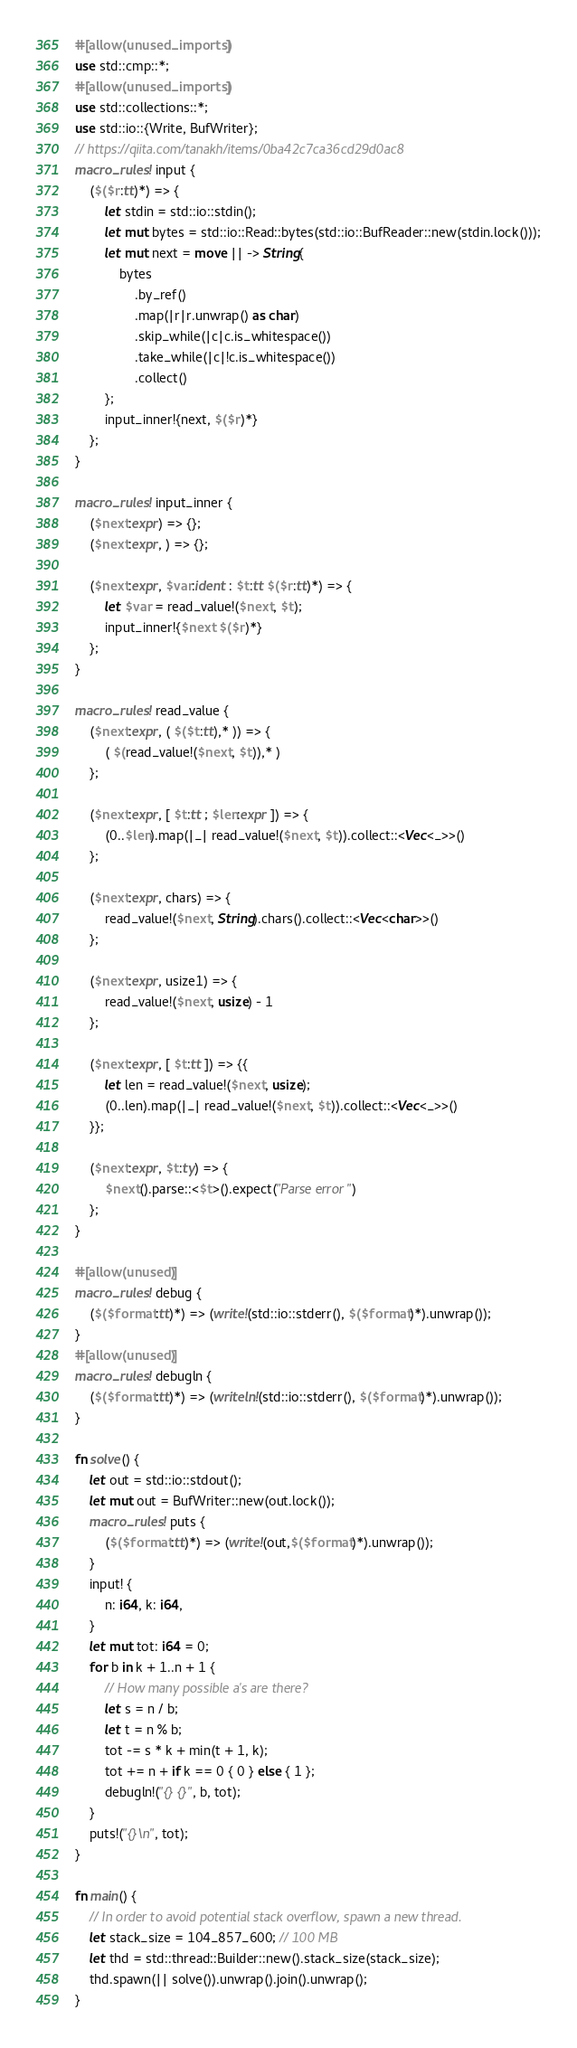Convert code to text. <code><loc_0><loc_0><loc_500><loc_500><_Rust_>#[allow(unused_imports)]
use std::cmp::*;
#[allow(unused_imports)]
use std::collections::*;
use std::io::{Write, BufWriter};
// https://qiita.com/tanakh/items/0ba42c7ca36cd29d0ac8
macro_rules! input {
    ($($r:tt)*) => {
        let stdin = std::io::stdin();
        let mut bytes = std::io::Read::bytes(std::io::BufReader::new(stdin.lock()));
        let mut next = move || -> String{
            bytes
                .by_ref()
                .map(|r|r.unwrap() as char)
                .skip_while(|c|c.is_whitespace())
                .take_while(|c|!c.is_whitespace())
                .collect()
        };
        input_inner!{next, $($r)*}
    };
}

macro_rules! input_inner {
    ($next:expr) => {};
    ($next:expr, ) => {};

    ($next:expr, $var:ident : $t:tt $($r:tt)*) => {
        let $var = read_value!($next, $t);
        input_inner!{$next $($r)*}
    };
}

macro_rules! read_value {
    ($next:expr, ( $($t:tt),* )) => {
        ( $(read_value!($next, $t)),* )
    };

    ($next:expr, [ $t:tt ; $len:expr ]) => {
        (0..$len).map(|_| read_value!($next, $t)).collect::<Vec<_>>()
    };

    ($next:expr, chars) => {
        read_value!($next, String).chars().collect::<Vec<char>>()
    };

    ($next:expr, usize1) => {
        read_value!($next, usize) - 1
    };

    ($next:expr, [ $t:tt ]) => {{
        let len = read_value!($next, usize);
        (0..len).map(|_| read_value!($next, $t)).collect::<Vec<_>>()
    }};

    ($next:expr, $t:ty) => {
        $next().parse::<$t>().expect("Parse error")
    };
}

#[allow(unused)]
macro_rules! debug {
    ($($format:tt)*) => (write!(std::io::stderr(), $($format)*).unwrap());
}
#[allow(unused)]
macro_rules! debugln {
    ($($format:tt)*) => (writeln!(std::io::stderr(), $($format)*).unwrap());
}

fn solve() {
    let out = std::io::stdout();
    let mut out = BufWriter::new(out.lock());
    macro_rules! puts {
        ($($format:tt)*) => (write!(out,$($format)*).unwrap());
    }
    input! {
        n: i64, k: i64,
    }
    let mut tot: i64 = 0;
    for b in k + 1..n + 1 {
        // How many possible a's are there?
        let s = n / b;
        let t = n % b;
        tot -= s * k + min(t + 1, k);
        tot += n + if k == 0 { 0 } else { 1 };
        debugln!("{} {}", b, tot);
    }
    puts!("{}\n", tot);
}

fn main() {
    // In order to avoid potential stack overflow, spawn a new thread.
    let stack_size = 104_857_600; // 100 MB
    let thd = std::thread::Builder::new().stack_size(stack_size);
    thd.spawn(|| solve()).unwrap().join().unwrap();
}
</code> 